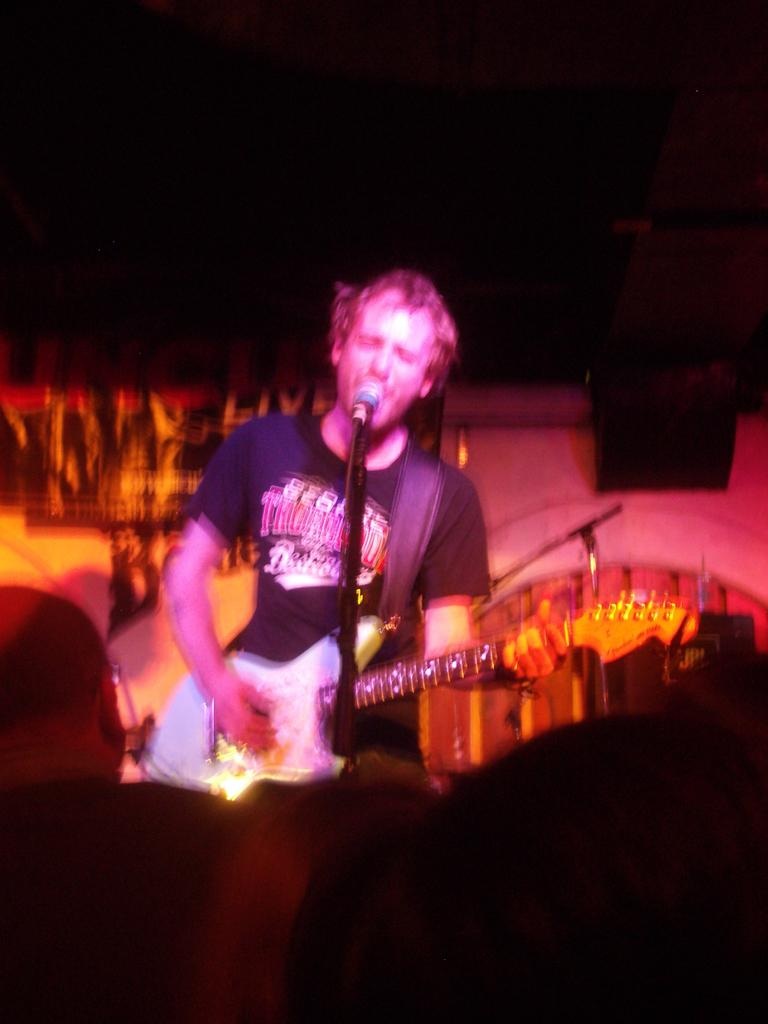What is the person in the image doing? The person is playing a guitar and singing a song. What is the person using to amplify their voice? There is a microphone in front of the person. What else can be seen in the image besides the person and the microphone? There are decorations and other musical instruments visible in the image. How does the person in the image stay cool while playing the guitar and singing? The image does not provide information about the person's temperature or any cooling methods, so we cannot answer this question. 